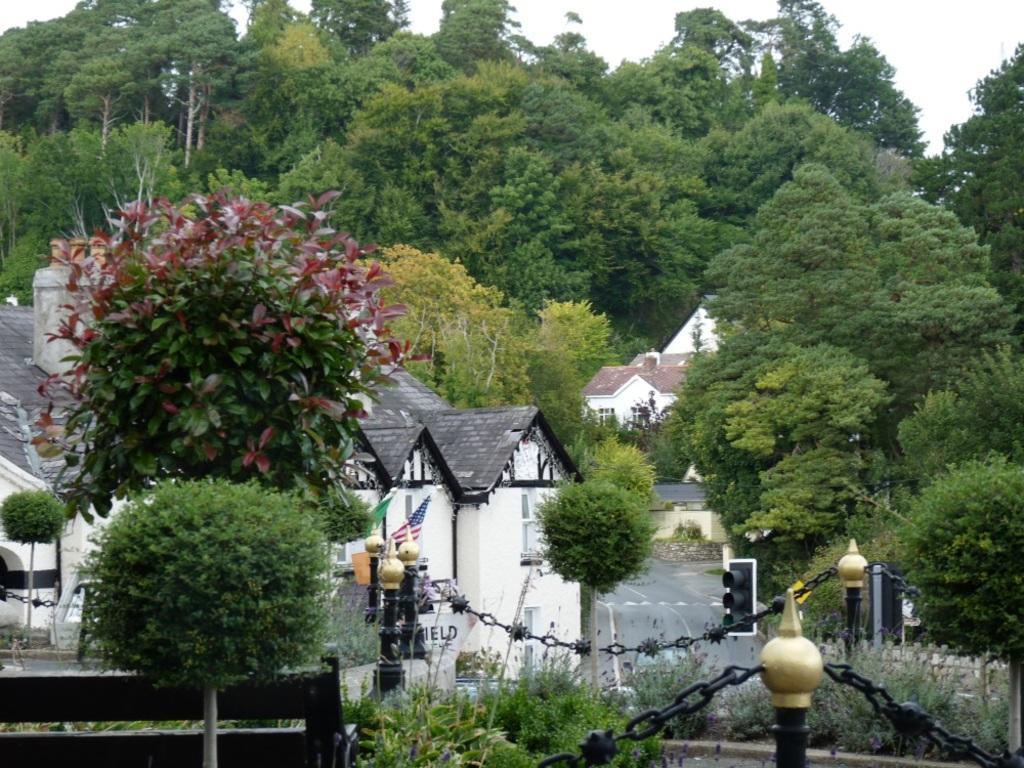Could you give a brief overview of what you see in this image? There are trees, houses, it seems like a boundary and a flag in the foreground area of the image, there are trees and the sky in the background. 